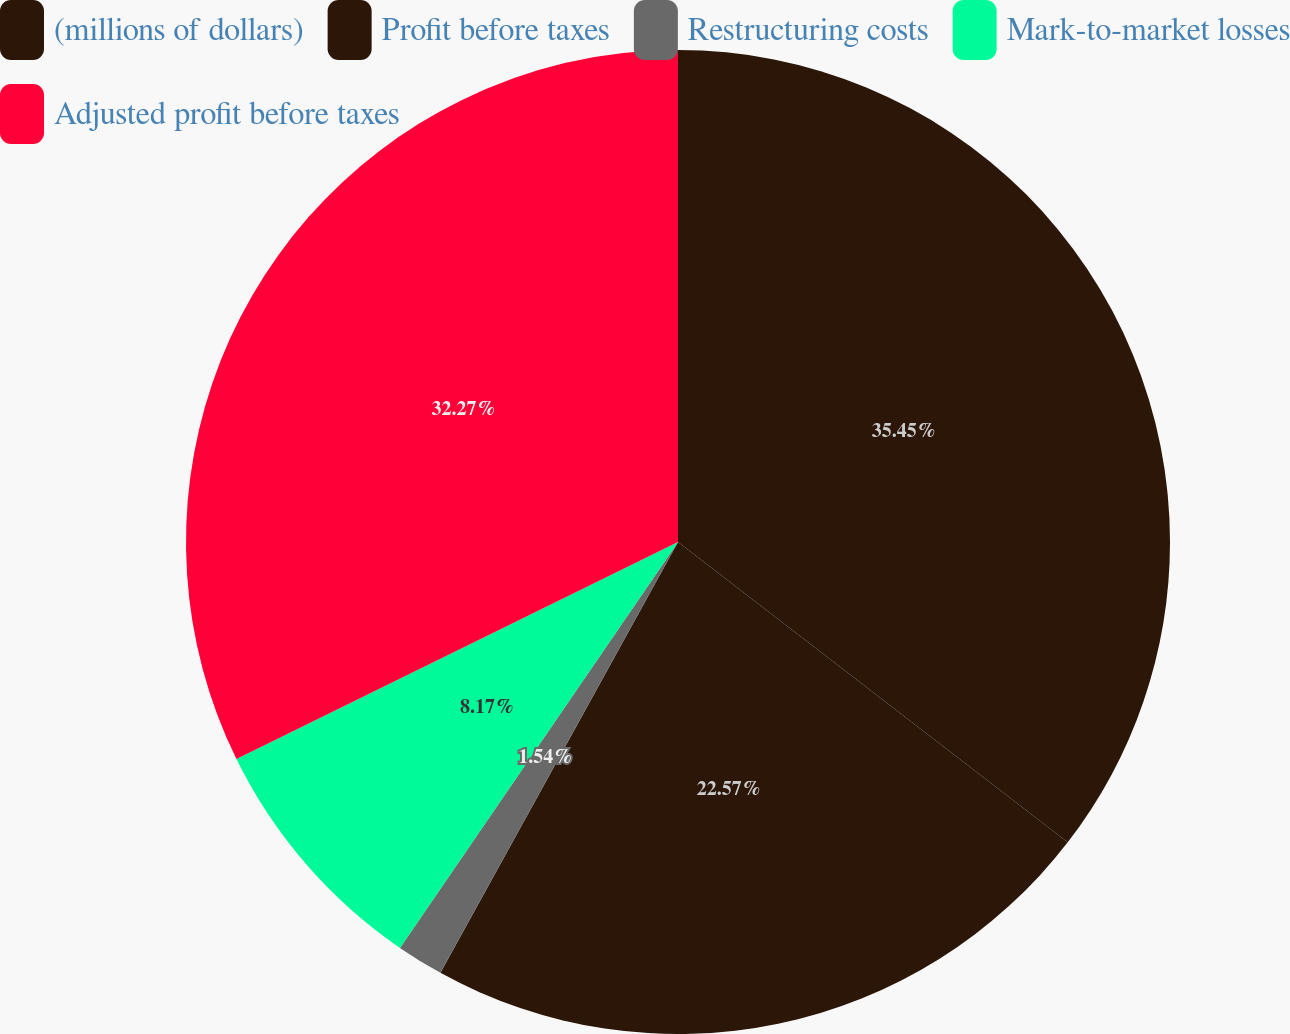Convert chart. <chart><loc_0><loc_0><loc_500><loc_500><pie_chart><fcel>(millions of dollars)<fcel>Profit before taxes<fcel>Restructuring costs<fcel>Mark-to-market losses<fcel>Adjusted profit before taxes<nl><fcel>35.45%<fcel>22.57%<fcel>1.54%<fcel>8.17%<fcel>32.27%<nl></chart> 